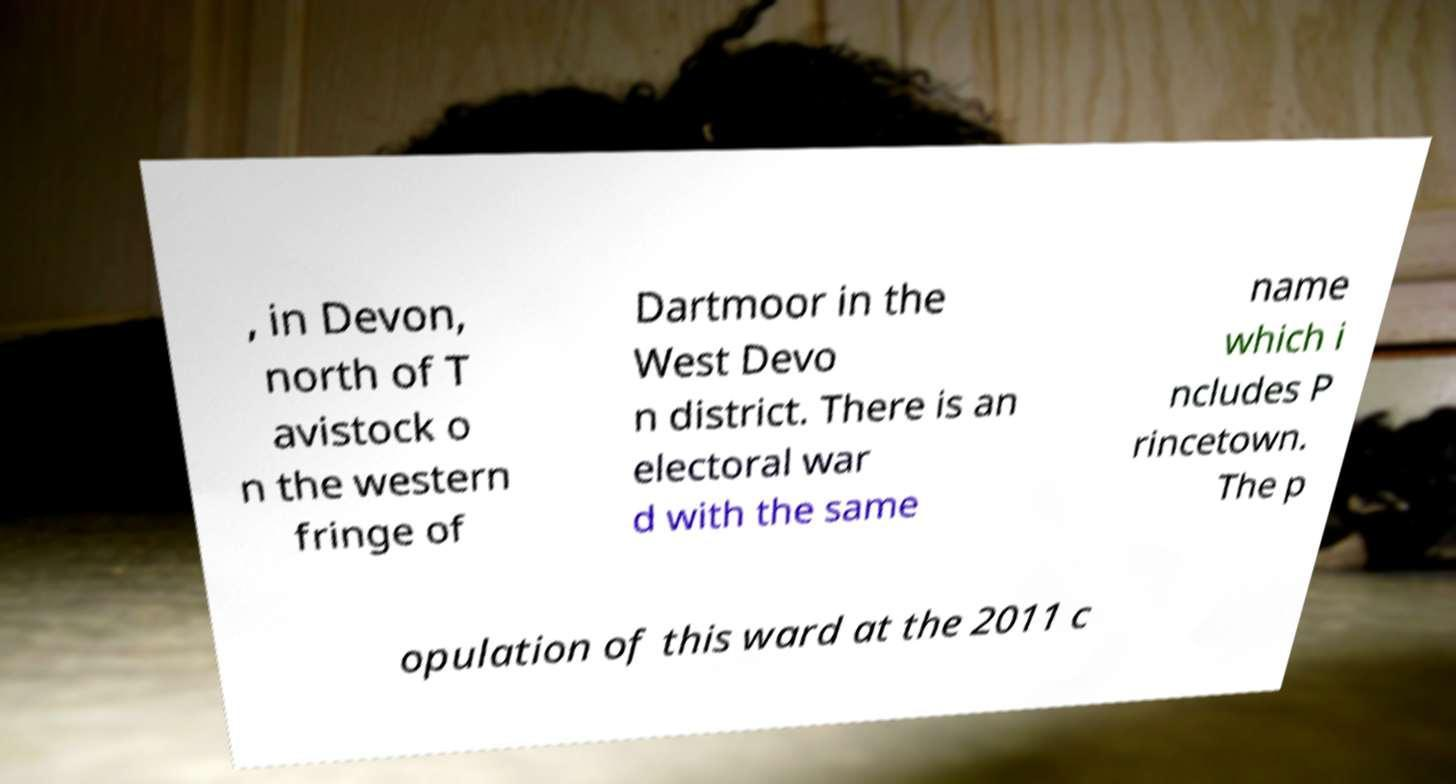Can you read and provide the text displayed in the image?This photo seems to have some interesting text. Can you extract and type it out for me? , in Devon, north of T avistock o n the western fringe of Dartmoor in the West Devo n district. There is an electoral war d with the same name which i ncludes P rincetown. The p opulation of this ward at the 2011 c 